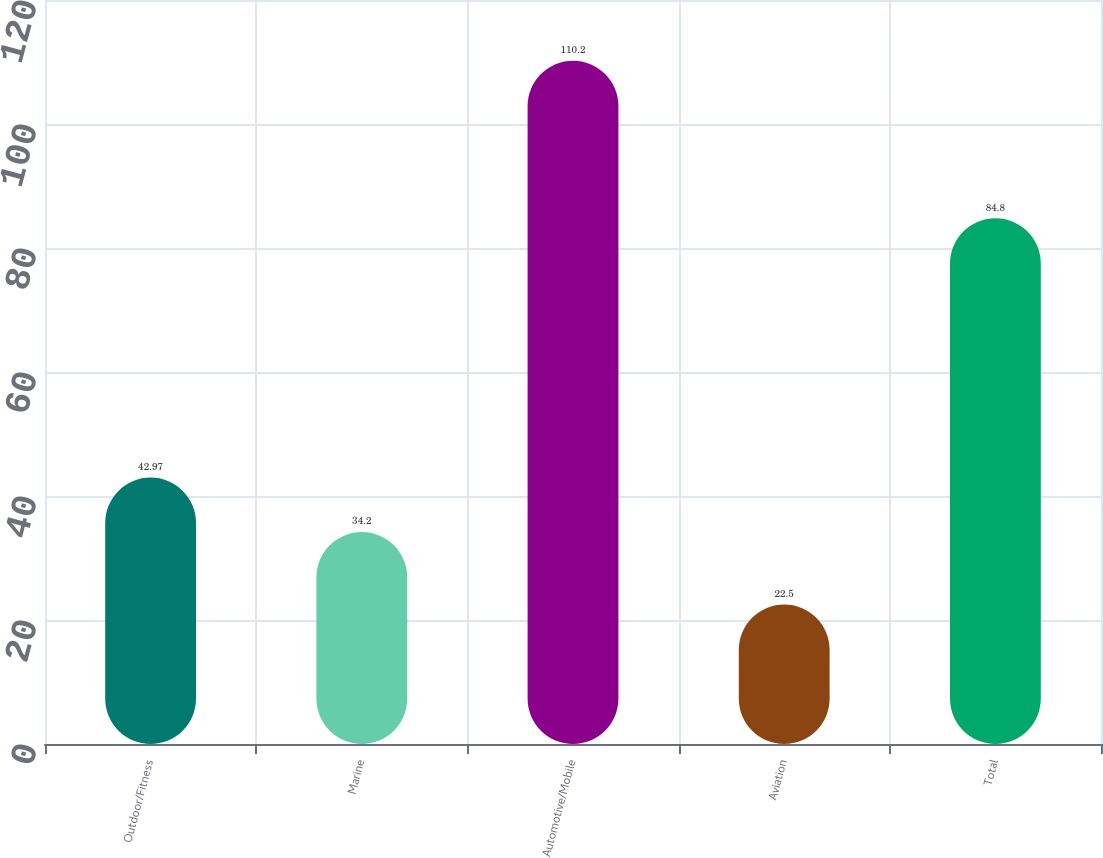<chart> <loc_0><loc_0><loc_500><loc_500><bar_chart><fcel>Outdoor/Fitness<fcel>Marine<fcel>Automotive/Mobile<fcel>Aviation<fcel>Total<nl><fcel>42.97<fcel>34.2<fcel>110.2<fcel>22.5<fcel>84.8<nl></chart> 